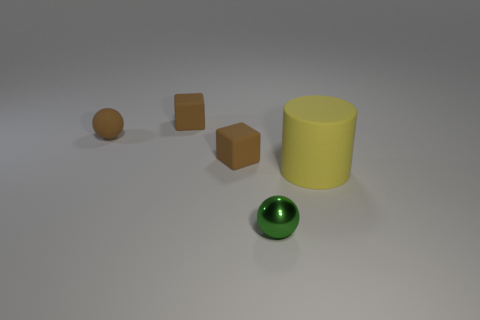Add 1 big yellow rubber cylinders. How many objects exist? 6 Subtract all blocks. How many objects are left? 3 Subtract 0 blue cubes. How many objects are left? 5 Subtract all big yellow cylinders. Subtract all big rubber cylinders. How many objects are left? 3 Add 5 large yellow rubber objects. How many large yellow rubber objects are left? 6 Add 3 cubes. How many cubes exist? 5 